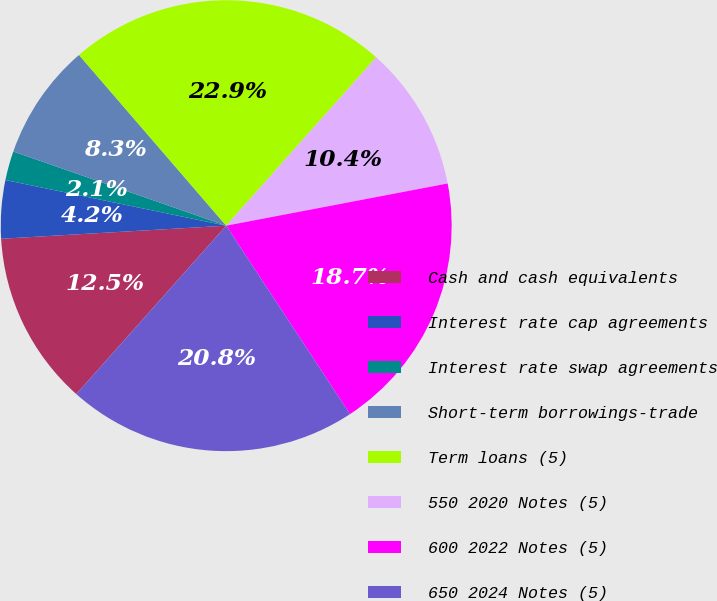Convert chart to OTSL. <chart><loc_0><loc_0><loc_500><loc_500><pie_chart><fcel>Cash and cash equivalents<fcel>Interest rate cap agreements<fcel>Interest rate swap agreements<fcel>Short-term borrowings-trade<fcel>Term loans (5)<fcel>550 2020 Notes (5)<fcel>600 2022 Notes (5)<fcel>650 2024 Notes (5)<nl><fcel>12.5%<fcel>4.17%<fcel>2.09%<fcel>8.34%<fcel>22.91%<fcel>10.42%<fcel>18.75%<fcel>20.83%<nl></chart> 